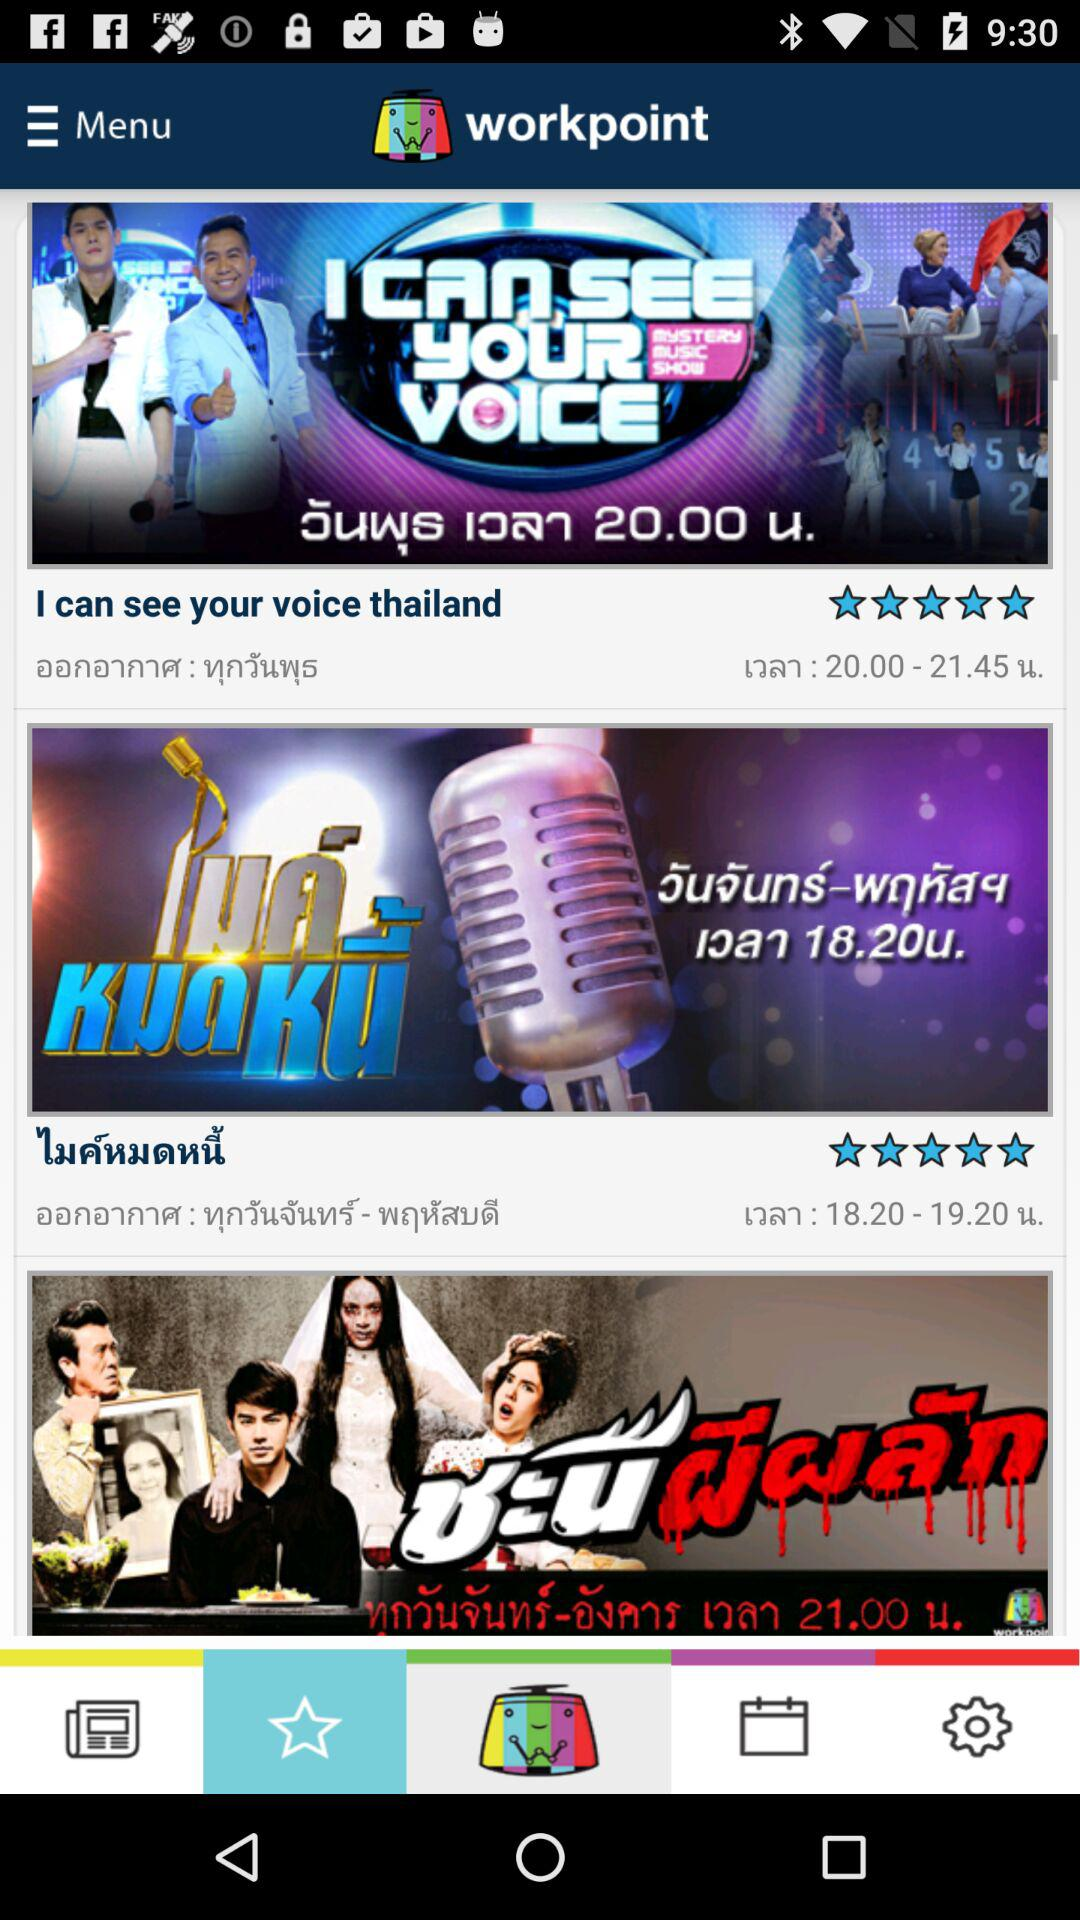How many programs are shown on the screen?
Answer the question using a single word or phrase. 3 